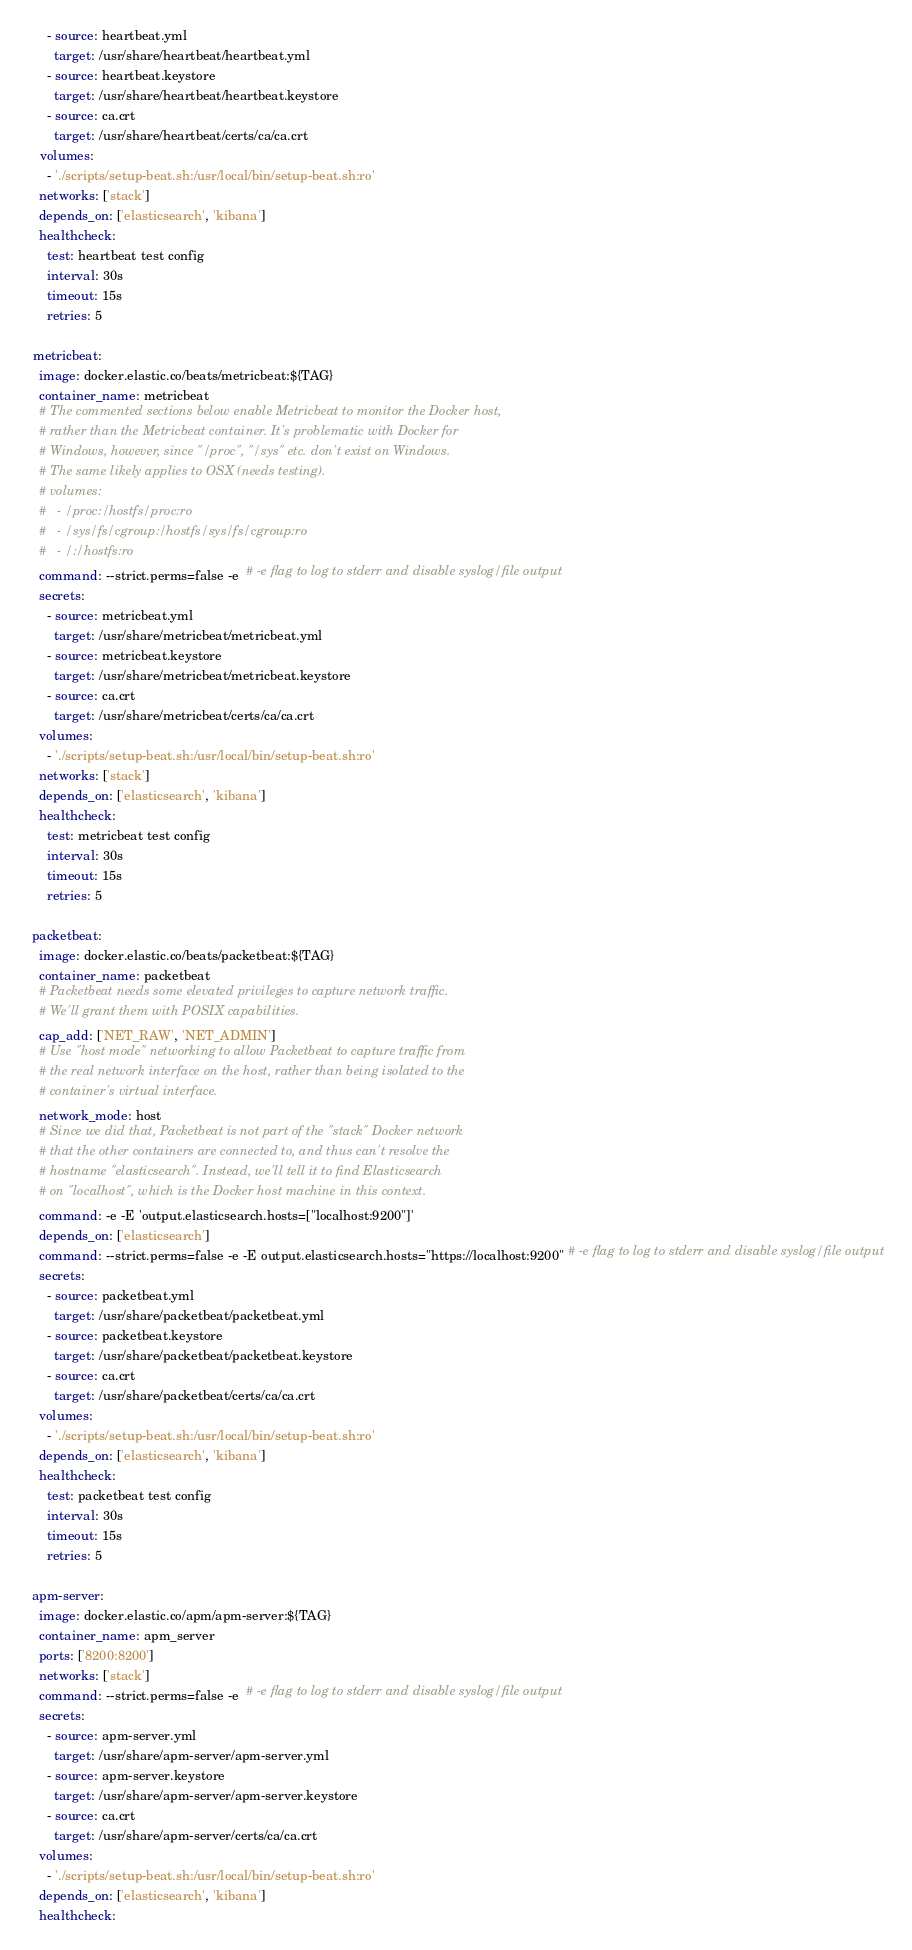Convert code to text. <code><loc_0><loc_0><loc_500><loc_500><_YAML_>      - source: heartbeat.yml
        target: /usr/share/heartbeat/heartbeat.yml
      - source: heartbeat.keystore
        target: /usr/share/heartbeat/heartbeat.keystore
      - source: ca.crt
        target: /usr/share/heartbeat/certs/ca/ca.crt
    volumes:
      - './scripts/setup-beat.sh:/usr/local/bin/setup-beat.sh:ro'
    networks: ['stack']
    depends_on: ['elasticsearch', 'kibana']
    healthcheck:
      test: heartbeat test config
      interval: 30s
      timeout: 15s
      retries: 5

  metricbeat:
    image: docker.elastic.co/beats/metricbeat:${TAG}
    container_name: metricbeat
    # The commented sections below enable Metricbeat to monitor the Docker host,
    # rather than the Metricbeat container. It's problematic with Docker for
    # Windows, however, since "/proc", "/sys" etc. don't exist on Windows.
    # The same likely applies to OSX (needs testing).
    # volumes:
    #   - /proc:/hostfs/proc:ro
    #   - /sys/fs/cgroup:/hostfs/sys/fs/cgroup:ro
    #   - /:/hostfs:ro
    command: --strict.perms=false -e  # -e flag to log to stderr and disable syslog/file output
    secrets:
      - source: metricbeat.yml
        target: /usr/share/metricbeat/metricbeat.yml
      - source: metricbeat.keystore
        target: /usr/share/metricbeat/metricbeat.keystore
      - source: ca.crt
        target: /usr/share/metricbeat/certs/ca/ca.crt
    volumes:
      - './scripts/setup-beat.sh:/usr/local/bin/setup-beat.sh:ro'
    networks: ['stack']
    depends_on: ['elasticsearch', 'kibana']
    healthcheck:
      test: metricbeat test config
      interval: 30s
      timeout: 15s
      retries: 5

  packetbeat:
    image: docker.elastic.co/beats/packetbeat:${TAG}
    container_name: packetbeat
    # Packetbeat needs some elevated privileges to capture network traffic.
    # We'll grant them with POSIX capabilities.
    cap_add: ['NET_RAW', 'NET_ADMIN']
    # Use "host mode" networking to allow Packetbeat to capture traffic from
    # the real network interface on the host, rather than being isolated to the
    # container's virtual interface.
    network_mode: host
    # Since we did that, Packetbeat is not part of the "stack" Docker network
    # that the other containers are connected to, and thus can't resolve the
    # hostname "elasticsearch". Instead, we'll tell it to find Elasticsearch
    # on "localhost", which is the Docker host machine in this context.
    command: -e -E 'output.elasticsearch.hosts=["localhost:9200"]'
    depends_on: ['elasticsearch']
    command: --strict.perms=false -e -E output.elasticsearch.hosts="https://localhost:9200" # -e flag to log to stderr and disable syslog/file output
    secrets:
      - source: packetbeat.yml
        target: /usr/share/packetbeat/packetbeat.yml
      - source: packetbeat.keystore
        target: /usr/share/packetbeat/packetbeat.keystore
      - source: ca.crt
        target: /usr/share/packetbeat/certs/ca/ca.crt
    volumes:
      - './scripts/setup-beat.sh:/usr/local/bin/setup-beat.sh:ro'
    depends_on: ['elasticsearch', 'kibana']
    healthcheck:
      test: packetbeat test config
      interval: 30s
      timeout: 15s
      retries: 5

  apm-server:
    image: docker.elastic.co/apm/apm-server:${TAG}
    container_name: apm_server
    ports: ['8200:8200']
    networks: ['stack']
    command: --strict.perms=false -e  # -e flag to log to stderr and disable syslog/file output
    secrets:
      - source: apm-server.yml
        target: /usr/share/apm-server/apm-server.yml
      - source: apm-server.keystore
        target: /usr/share/apm-server/apm-server.keystore
      - source: ca.crt
        target: /usr/share/apm-server/certs/ca/ca.crt
    volumes:
      - './scripts/setup-beat.sh:/usr/local/bin/setup-beat.sh:ro'
    depends_on: ['elasticsearch', 'kibana']
    healthcheck:</code> 